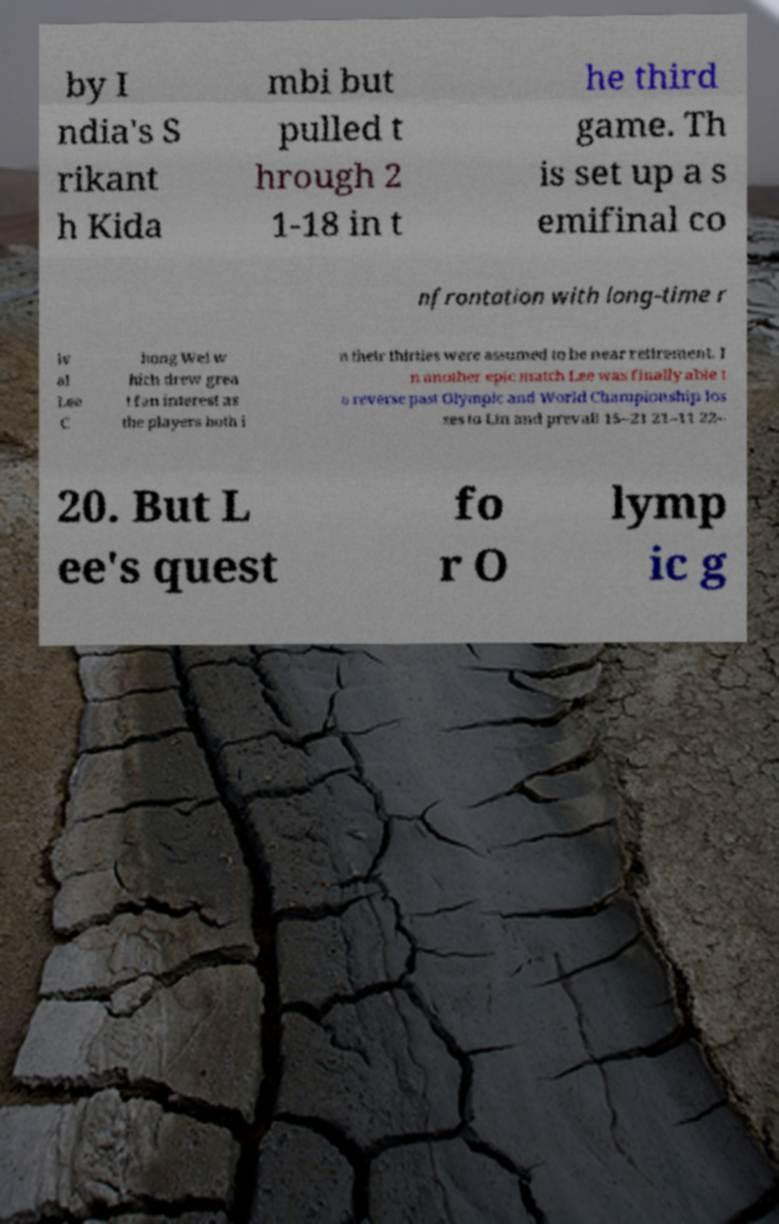I need the written content from this picture converted into text. Can you do that? by I ndia's S rikant h Kida mbi but pulled t hrough 2 1-18 in t he third game. Th is set up a s emifinal co nfrontation with long-time r iv al Lee C hong Wei w hich drew grea t fan interest as the players both i n their thirties were assumed to be near retirement. I n another epic match Lee was finally able t o reverse past Olympic and World Championship los ses to Lin and prevail 15–21 21–11 22– 20. But L ee's quest fo r O lymp ic g 